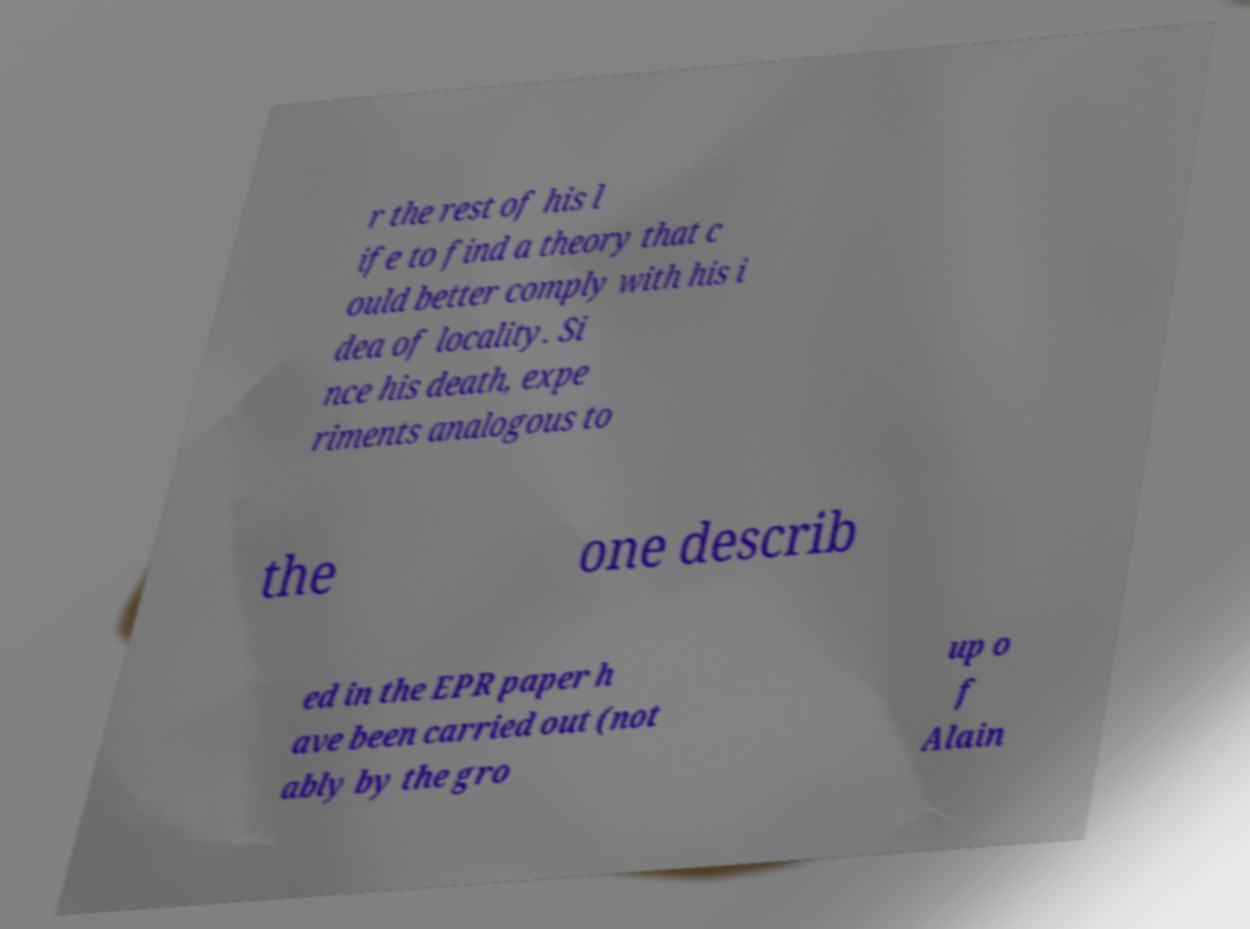Could you assist in decoding the text presented in this image and type it out clearly? r the rest of his l ife to find a theory that c ould better comply with his i dea of locality. Si nce his death, expe riments analogous to the one describ ed in the EPR paper h ave been carried out (not ably by the gro up o f Alain 